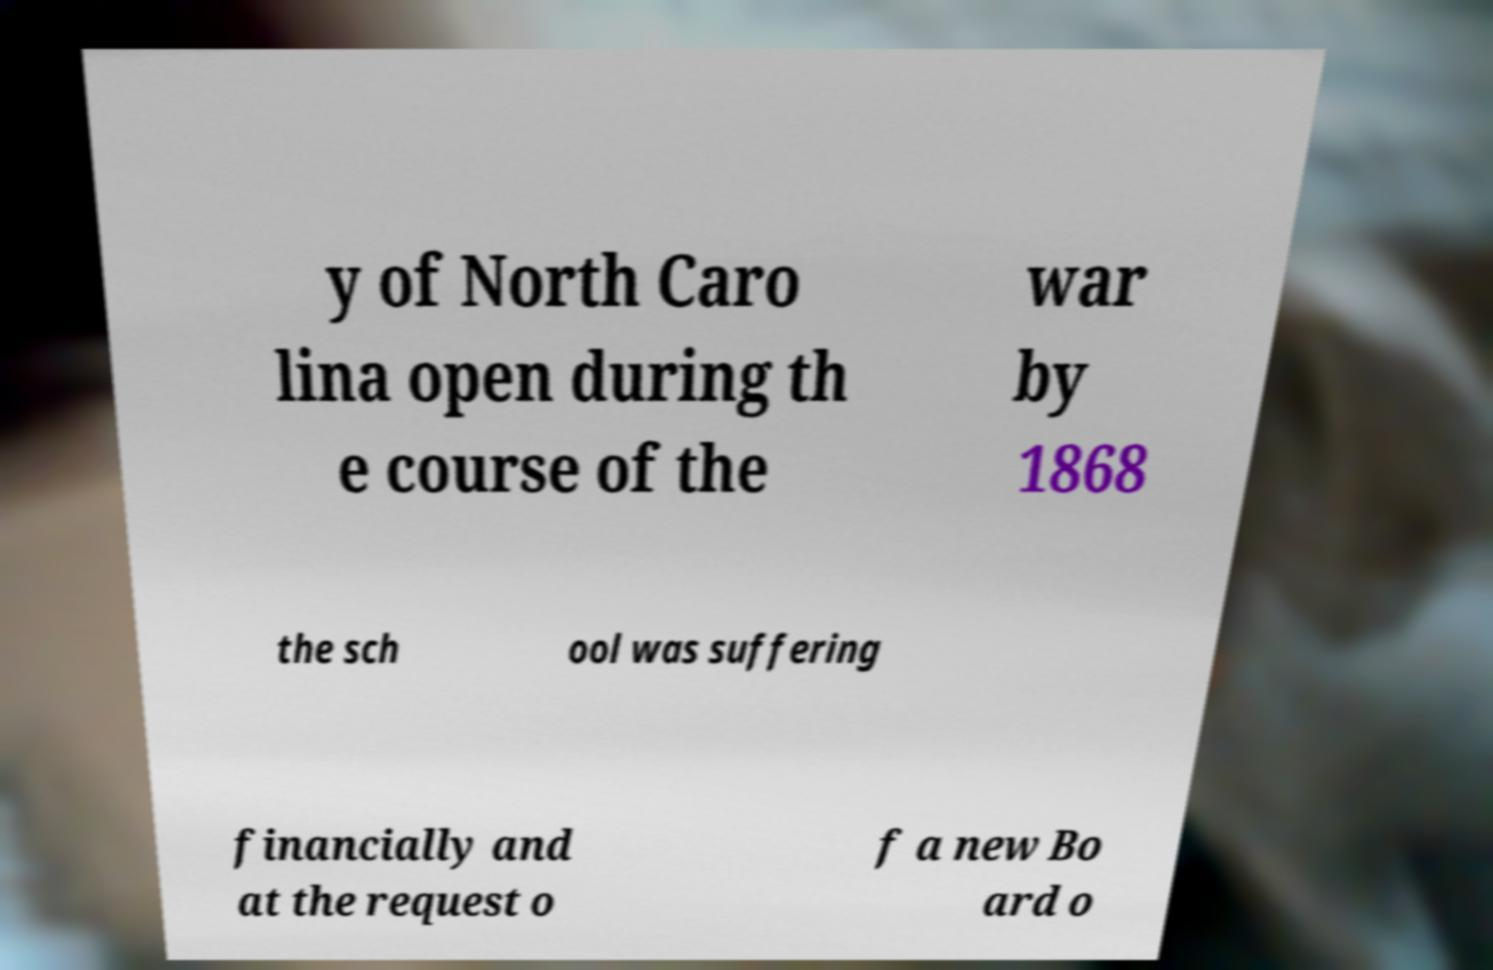Could you extract and type out the text from this image? y of North Caro lina open during th e course of the war by 1868 the sch ool was suffering financially and at the request o f a new Bo ard o 